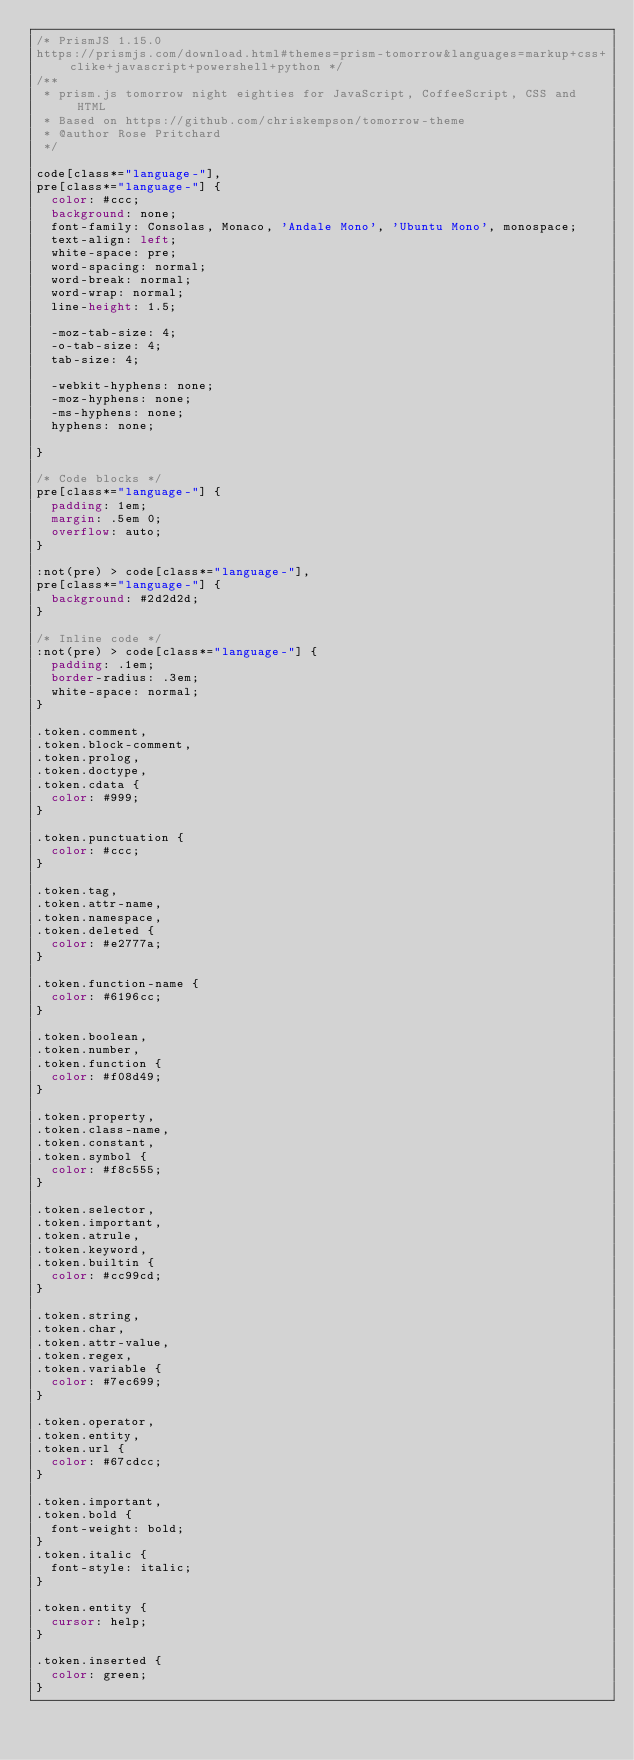<code> <loc_0><loc_0><loc_500><loc_500><_CSS_>/* PrismJS 1.15.0
https://prismjs.com/download.html#themes=prism-tomorrow&languages=markup+css+clike+javascript+powershell+python */
/**
 * prism.js tomorrow night eighties for JavaScript, CoffeeScript, CSS and HTML
 * Based on https://github.com/chriskempson/tomorrow-theme
 * @author Rose Pritchard
 */

code[class*="language-"],
pre[class*="language-"] {
	color: #ccc;
	background: none;
	font-family: Consolas, Monaco, 'Andale Mono', 'Ubuntu Mono', monospace;
	text-align: left;
	white-space: pre;
	word-spacing: normal;
	word-break: normal;
	word-wrap: normal;
	line-height: 1.5;

	-moz-tab-size: 4;
	-o-tab-size: 4;
	tab-size: 4;

	-webkit-hyphens: none;
	-moz-hyphens: none;
	-ms-hyphens: none;
	hyphens: none;

}

/* Code blocks */
pre[class*="language-"] {
	padding: 1em;
	margin: .5em 0;
	overflow: auto;
}

:not(pre) > code[class*="language-"],
pre[class*="language-"] {
	background: #2d2d2d;
}

/* Inline code */
:not(pre) > code[class*="language-"] {
	padding: .1em;
	border-radius: .3em;
	white-space: normal;
}

.token.comment,
.token.block-comment,
.token.prolog,
.token.doctype,
.token.cdata {
	color: #999;
}

.token.punctuation {
	color: #ccc;
}

.token.tag,
.token.attr-name,
.token.namespace,
.token.deleted {
	color: #e2777a;
}

.token.function-name {
	color: #6196cc;
}

.token.boolean,
.token.number,
.token.function {
	color: #f08d49;
}

.token.property,
.token.class-name,
.token.constant,
.token.symbol {
	color: #f8c555;
}

.token.selector,
.token.important,
.token.atrule,
.token.keyword,
.token.builtin {
	color: #cc99cd;
}

.token.string,
.token.char,
.token.attr-value,
.token.regex,
.token.variable {
	color: #7ec699;
}

.token.operator,
.token.entity,
.token.url {
	color: #67cdcc;
}

.token.important,
.token.bold {
	font-weight: bold;
}
.token.italic {
	font-style: italic;
}

.token.entity {
	cursor: help;
}

.token.inserted {
	color: green;
}

</code> 